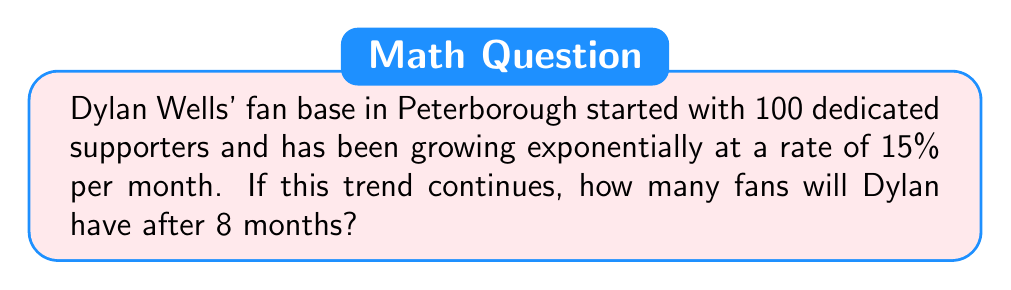Give your solution to this math problem. Let's approach this step-by-step:

1) The initial number of fans is 100.
2) The growth rate is 15% per month, which as a decimal is 0.15.
3) We need to calculate the number of fans after 8 months.

We can use the exponential growth formula:

$$A = P(1 + r)^t$$

Where:
$A$ = Final amount
$P$ = Initial amount (principal)
$r$ = Growth rate (as a decimal)
$t$ = Time period

Substituting our values:

$$A = 100(1 + 0.15)^8$$

Now, let's calculate:

$$A = 100(1.15)^8$$
$$A = 100 \times 3.0590$$
$$A = 305.90$$

Rounding to the nearest whole number (as we can't have a fractional fan):

$$A \approx 306$$
Answer: 306 fans 